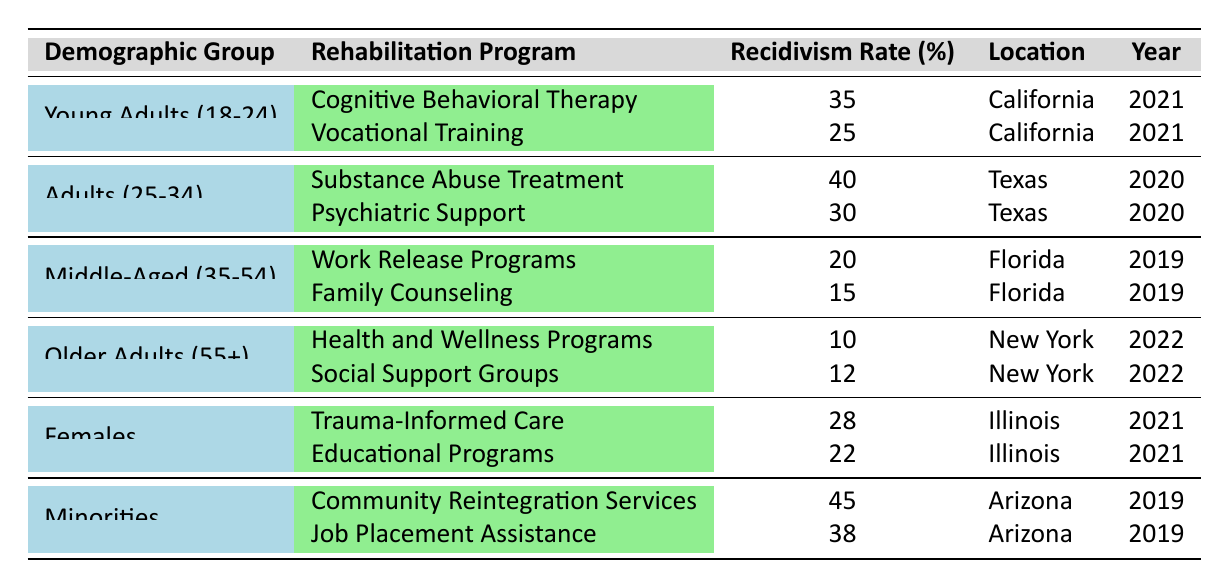What is the recidivism rate for young adults participating in vocational training? The table shows that the recidivism rate for young adults (18-24) participating in vocational training in California in 2021 is 25%.
Answer: 25% Which demographic group has the lowest recidivism rate? The table indicates that the recidivism rate for older adults (55+) in health and wellness programs is the lowest at 10%.
Answer: 10% What was the recidivism rate for females receiving educational programs? According to the table, the recidivism rate for females in educational programs in Illinois in 2021 is 22%.
Answer: 22% Which rehabilitation program showed the highest recidivism rate among minorities? The table lists that community reintegration services for minorities in Arizona in 2019 had the highest recidivism rate at 45%.
Answer: 45% What is the average recidivism rate for older adults across both rehabilitation programs shown? The recidivism rates for older adults (55+) are 10% for health and wellness programs and 12% for social support groups. The average is (10 + 12) / 2 = 11%.
Answer: 11% Is the recidivism rate for trauma-informed care among females higher or lower than that for substance abuse treatment among adults? The recidivism rate for females in trauma-informed care is 28%, while the rate for adults in substance abuse treatment is 40%. Therefore, 28% is lower than 40%.
Answer: Lower What is the difference in recidivism rates between vocational training and cognitive behavioral therapy for young adults? The recidivism rate for vocational training is 25% and for cognitive behavioral therapy is 35%. The difference is 35 - 25 = 10%.
Answer: 10% Which demographic has the highest recidivism rate for any rehabilitation program listed? The minority demographic has the highest recidivism rate at 45% for community reintegration services in Arizona in 2019.
Answer: 45% If we combine the recidivism rates of all rehabilitation programs for middle-aged adults, what is the total? The rates for middle-aged adults are 20% for work release programs and 15% for family counseling. The total is 20 + 15 = 35%.
Answer: 35% In what year was the recidivism rate lowest for older adults participating in health and wellness programs? The table shows that the recidivism rate for older adults in health and wellness programs in New York was 10% in 2022, which is its only instance in the data.
Answer: 2022 